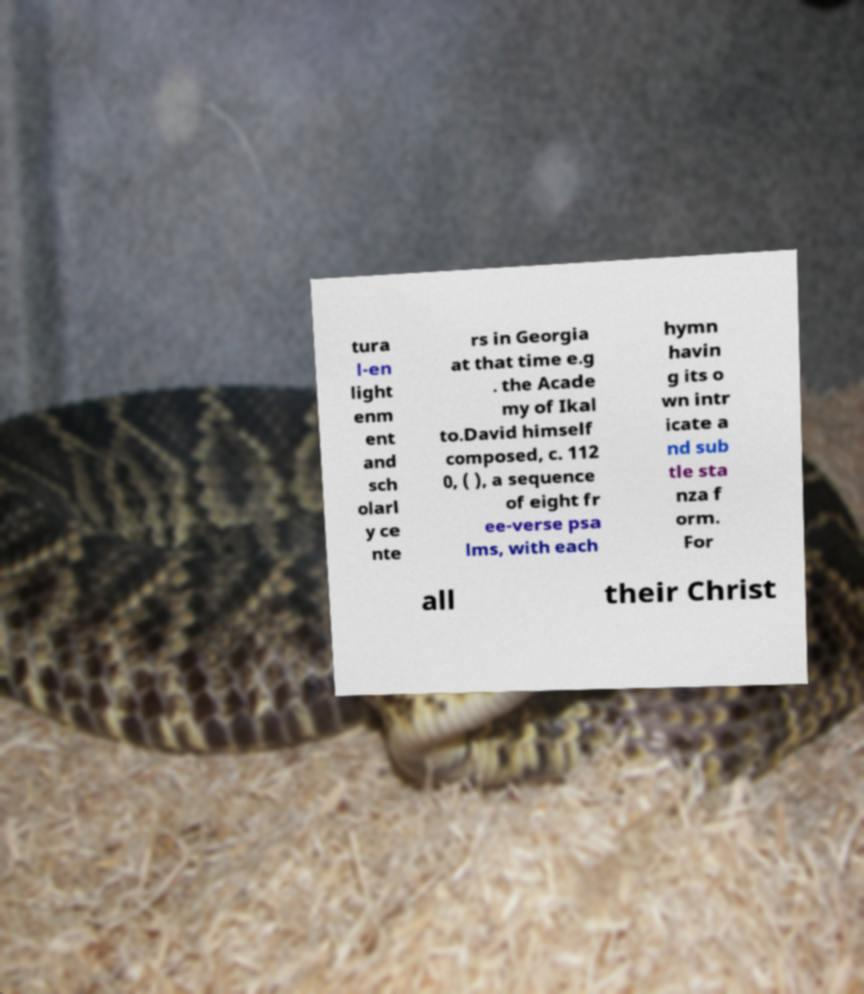I need the written content from this picture converted into text. Can you do that? tura l-en light enm ent and sch olarl y ce nte rs in Georgia at that time e.g . the Acade my of Ikal to.David himself composed, c. 112 0, ( ), a sequence of eight fr ee-verse psa lms, with each hymn havin g its o wn intr icate a nd sub tle sta nza f orm. For all their Christ 